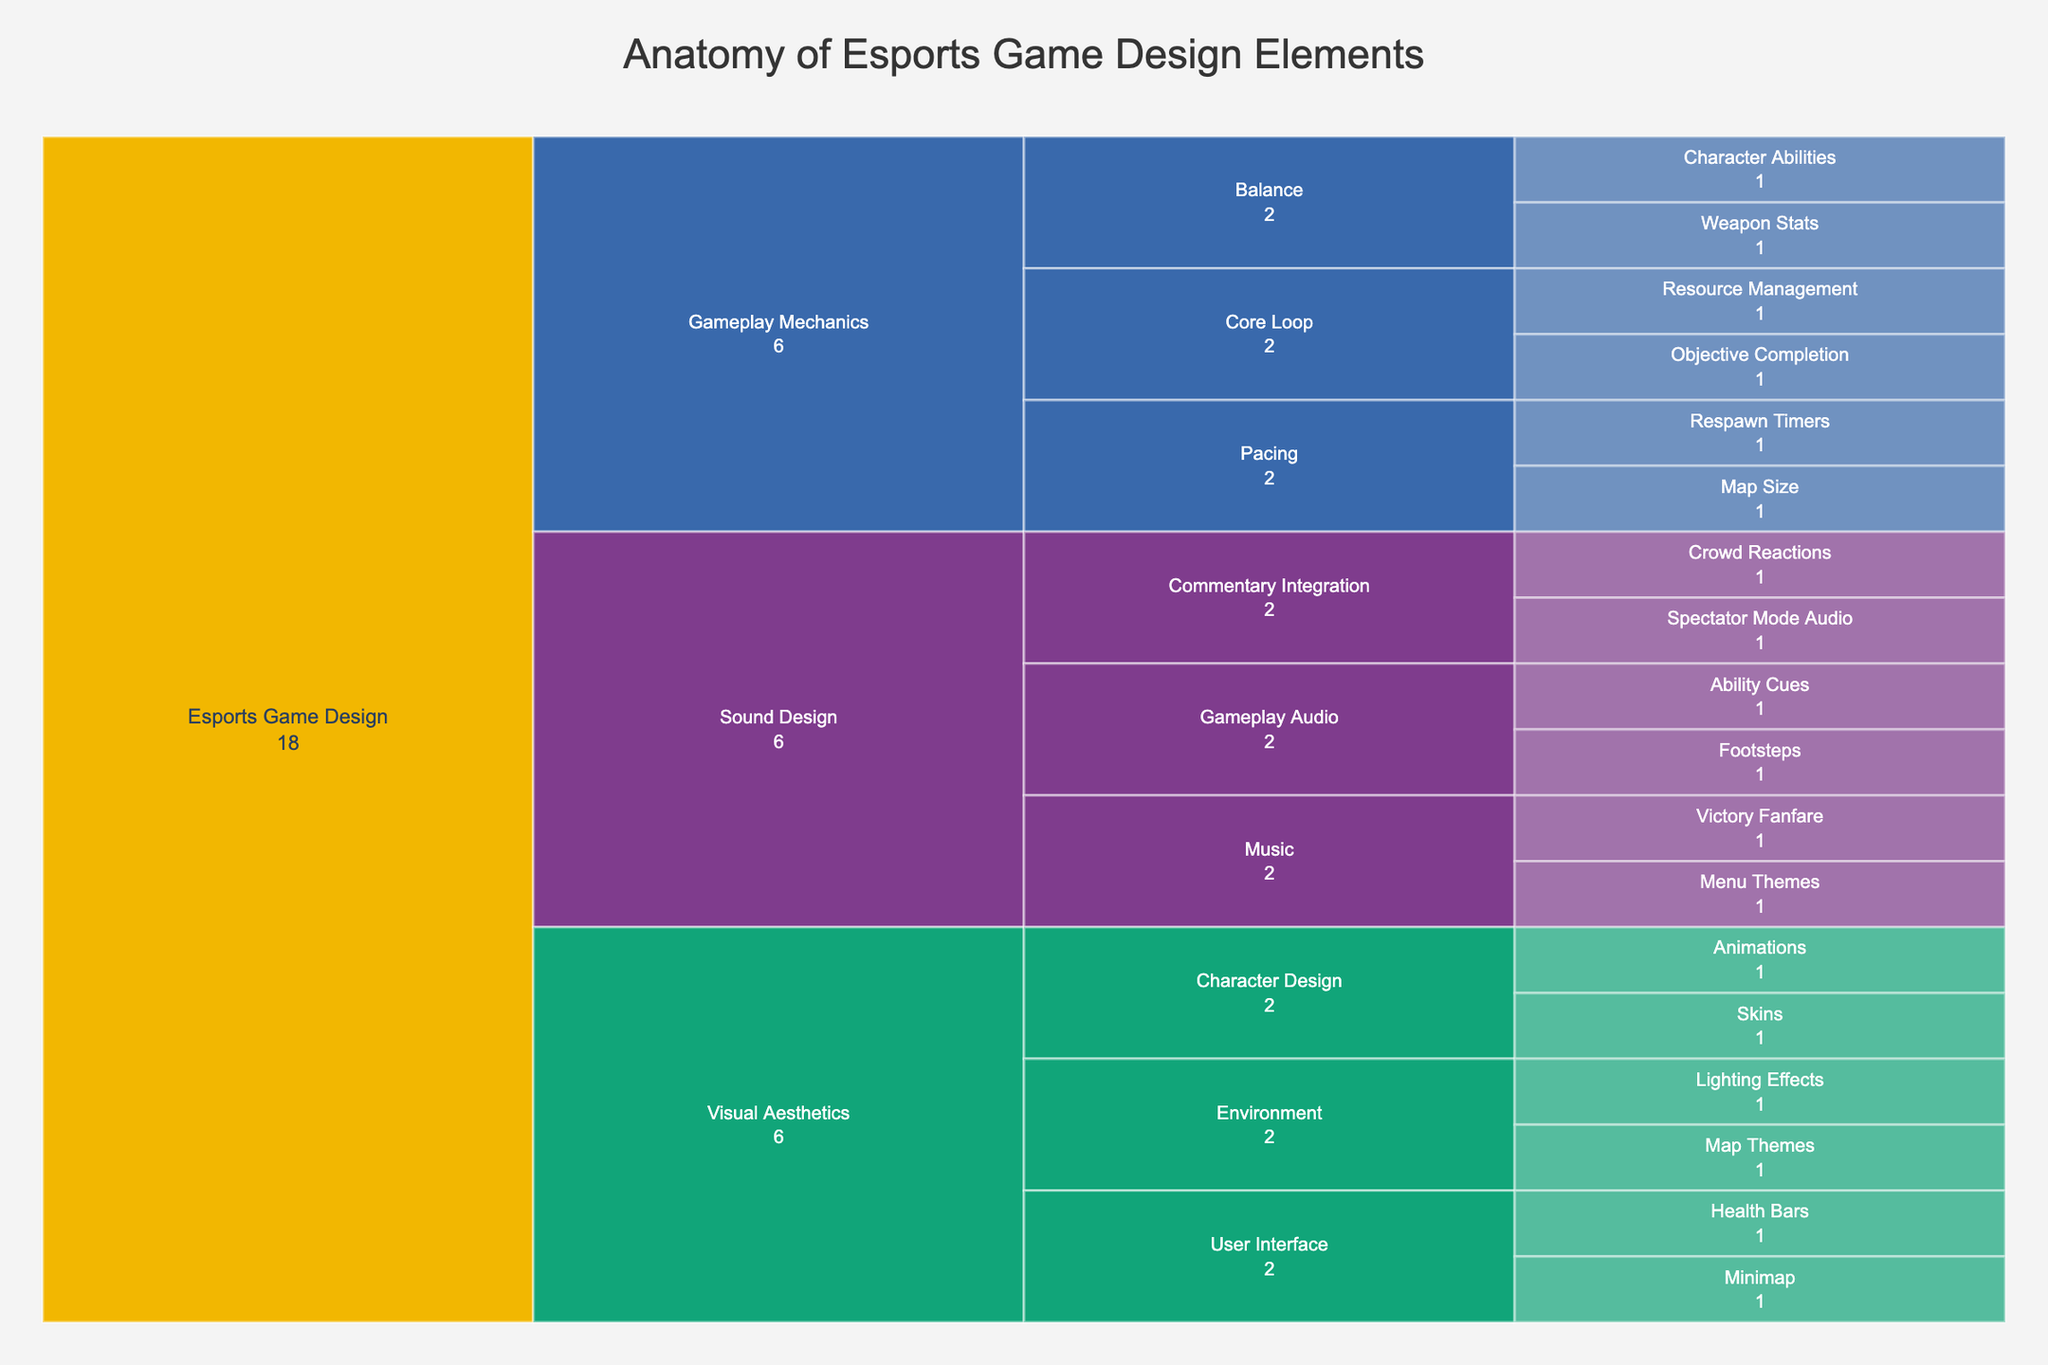What's the title of the figure? The title is usually displayed at the top of the chart. In this case, from the code, it is "Anatomy of Esports Game Design Elements".
Answer: Anatomy of Esports Game Design Elements What are the three main categories displayed in the figure? The icicle chart organizes data hierarchically. The three main categories listed at the top level under "Esports Game Design" are "Gameplay Mechanics," "Visual Aesthetics," and "Sound Design."
Answer: Gameplay Mechanics, Visual Aesthetics, Sound Design Which subcategory under Gameplay Mechanics has more than one element? Observe the breakout from "Gameplay Mechanics"; the subcategories with multiple elements are "Core Loop," "Balance," and "Pacing." Each of these has two elements.
Answer: Core Loop, Balance, Pacing How many elements fall under the category of Sound Design? Count the number of elements listed under each subcategory within "Sound Design": Ability Cues, Footsteps, Menu Themes, Victory Fanfare, Spectator Mode Audio, and Crowd Reactions.
Answer: 6 elements Which gameplay mechanics subcategory is associated with Respawn Timers? Trace back the path from the element "Respawn Timers." It falls under "Pacing," which is a subcategory of "Gameplay Mechanics."
Answer: Pacing Compare the number of elements between the subcategories User Interface and Character Design under Visual Aesthetics. Which one has more elements? User Interface has "Minimap" and "Health Bars," totaling two elements. Character Design includes "Skins" and "Animations," also totaling two elements. Therefore, they have an equal number of elements.
Answer: Equal (2 each) What is the difference in the number of elements between the categories Gameplay Mechanics and Sound Design? Gameplay Mechanics has six elements: Resource Management, Objective Completion, Character Abilities, Weapon Stats, Respawn Timers, Map Size. Sound Design also has six elements: Ability Cues, Footsteps, Menu Themes, Victory Fanfare, Spectator Mode Audio, Crowd Reactions. The difference is zero.
Answer: 0 Among Map Themes and Lighting Effects, which one belongs to the subcategory Environment? Both "Map Themes" and "Lighting Effects" fall under the subcategory "Environment" within "Visual Aesthetics."
Answer: Both What is the ratio of elements between Character Design and Environment under Visual Aesthetics? Character Design has 2 elements ("Skins" and "Animations"). Environment also has 2 elements ("Map Themes" and "Lighting Effects"). Thus, the ratio is 2:2, which simplifies to 1:1.
Answer: 1:1 